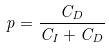<formula> <loc_0><loc_0><loc_500><loc_500>p = \frac { C _ { D } } { C _ { I } + C _ { D } }</formula> 